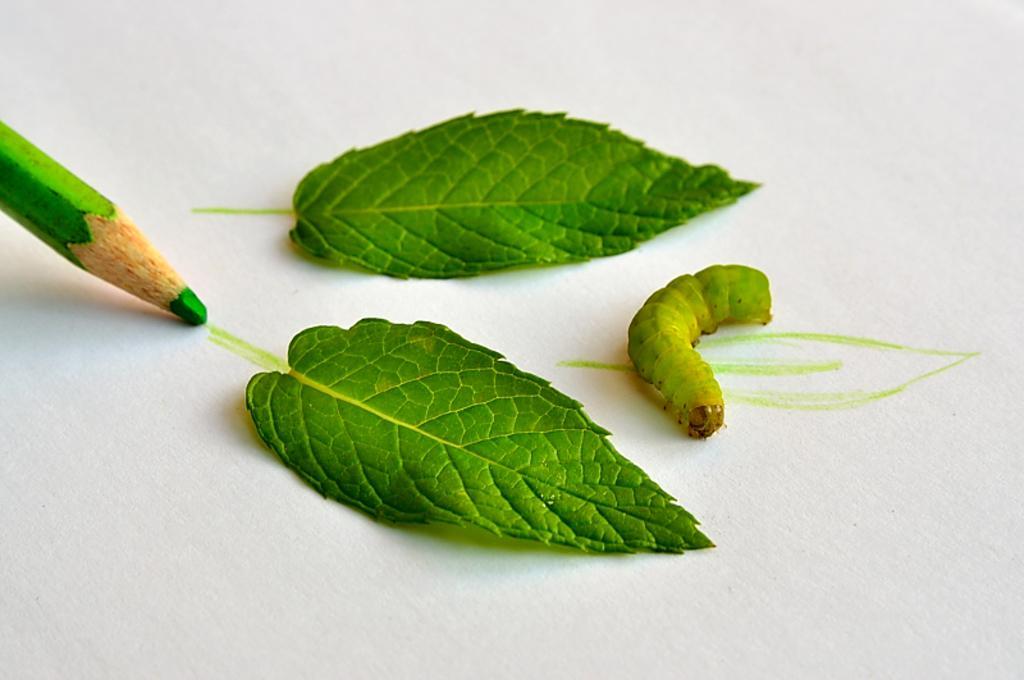In one or two sentences, can you explain what this image depicts? In the picture we can see a white surface on it, we can see two leaves and a caterpillar which are green in color and a green color pencil which is drawing something on the white surface. 